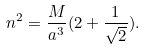Convert formula to latex. <formula><loc_0><loc_0><loc_500><loc_500>n ^ { 2 } = \frac { M } { a ^ { 3 } } ( 2 + \frac { 1 } { \sqrt { 2 } } ) .</formula> 